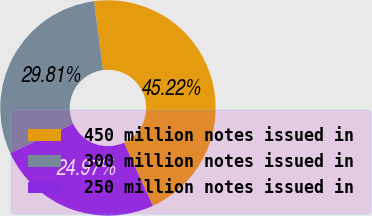Convert chart to OTSL. <chart><loc_0><loc_0><loc_500><loc_500><pie_chart><fcel>450 million notes issued in<fcel>300 million notes issued in<fcel>250 million notes issued in<nl><fcel>45.22%<fcel>29.81%<fcel>24.97%<nl></chart> 